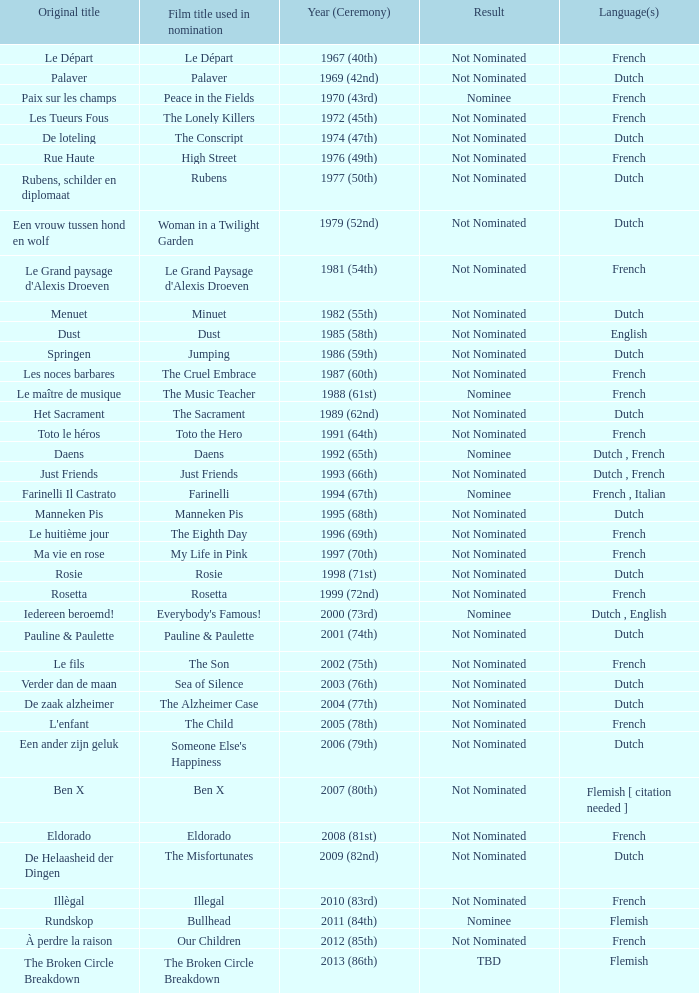What was the title used for Rosie, the film nominated for the dutch language? Rosie. Could you parse the entire table? {'header': ['Original title', 'Film title used in nomination', 'Year (Ceremony)', 'Result', 'Language(s)'], 'rows': [['Le Départ', 'Le Départ', '1967 (40th)', 'Not Nominated', 'French'], ['Palaver', 'Palaver', '1969 (42nd)', 'Not Nominated', 'Dutch'], ['Paix sur les champs', 'Peace in the Fields', '1970 (43rd)', 'Nominee', 'French'], ['Les Tueurs Fous', 'The Lonely Killers', '1972 (45th)', 'Not Nominated', 'French'], ['De loteling', 'The Conscript', '1974 (47th)', 'Not Nominated', 'Dutch'], ['Rue Haute', 'High Street', '1976 (49th)', 'Not Nominated', 'French'], ['Rubens, schilder en diplomaat', 'Rubens', '1977 (50th)', 'Not Nominated', 'Dutch'], ['Een vrouw tussen hond en wolf', 'Woman in a Twilight Garden', '1979 (52nd)', 'Not Nominated', 'Dutch'], ["Le Grand paysage d'Alexis Droeven", "Le Grand Paysage d'Alexis Droeven", '1981 (54th)', 'Not Nominated', 'French'], ['Menuet', 'Minuet', '1982 (55th)', 'Not Nominated', 'Dutch'], ['Dust', 'Dust', '1985 (58th)', 'Not Nominated', 'English'], ['Springen', 'Jumping', '1986 (59th)', 'Not Nominated', 'Dutch'], ['Les noces barbares', 'The Cruel Embrace', '1987 (60th)', 'Not Nominated', 'French'], ['Le maître de musique', 'The Music Teacher', '1988 (61st)', 'Nominee', 'French'], ['Het Sacrament', 'The Sacrament', '1989 (62nd)', 'Not Nominated', 'Dutch'], ['Toto le héros', 'Toto the Hero', '1991 (64th)', 'Not Nominated', 'French'], ['Daens', 'Daens', '1992 (65th)', 'Nominee', 'Dutch , French'], ['Just Friends', 'Just Friends', '1993 (66th)', 'Not Nominated', 'Dutch , French'], ['Farinelli Il Castrato', 'Farinelli', '1994 (67th)', 'Nominee', 'French , Italian'], ['Manneken Pis', 'Manneken Pis', '1995 (68th)', 'Not Nominated', 'Dutch'], ['Le huitième jour', 'The Eighth Day', '1996 (69th)', 'Not Nominated', 'French'], ['Ma vie en rose', 'My Life in Pink', '1997 (70th)', 'Not Nominated', 'French'], ['Rosie', 'Rosie', '1998 (71st)', 'Not Nominated', 'Dutch'], ['Rosetta', 'Rosetta', '1999 (72nd)', 'Not Nominated', 'French'], ['Iedereen beroemd!', "Everybody's Famous!", '2000 (73rd)', 'Nominee', 'Dutch , English'], ['Pauline & Paulette', 'Pauline & Paulette', '2001 (74th)', 'Not Nominated', 'Dutch'], ['Le fils', 'The Son', '2002 (75th)', 'Not Nominated', 'French'], ['Verder dan de maan', 'Sea of Silence', '2003 (76th)', 'Not Nominated', 'Dutch'], ['De zaak alzheimer', 'The Alzheimer Case', '2004 (77th)', 'Not Nominated', 'Dutch'], ["L'enfant", 'The Child', '2005 (78th)', 'Not Nominated', 'French'], ['Een ander zijn geluk', "Someone Else's Happiness", '2006 (79th)', 'Not Nominated', 'Dutch'], ['Ben X', 'Ben X', '2007 (80th)', 'Not Nominated', 'Flemish [ citation needed ]'], ['Eldorado', 'Eldorado', '2008 (81st)', 'Not Nominated', 'French'], ['De Helaasheid der Dingen', 'The Misfortunates', '2009 (82nd)', 'Not Nominated', 'Dutch'], ['Illègal', 'Illegal', '2010 (83rd)', 'Not Nominated', 'French'], ['Rundskop', 'Bullhead', '2011 (84th)', 'Nominee', 'Flemish'], ['À perdre la raison', 'Our Children', '2012 (85th)', 'Not Nominated', 'French'], ['The Broken Circle Breakdown', 'The Broken Circle Breakdown', '2013 (86th)', 'TBD', 'Flemish']]} 